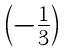<formula> <loc_0><loc_0><loc_500><loc_500>\begin{pmatrix} - \frac { 1 } { 3 } \end{pmatrix}</formula> 